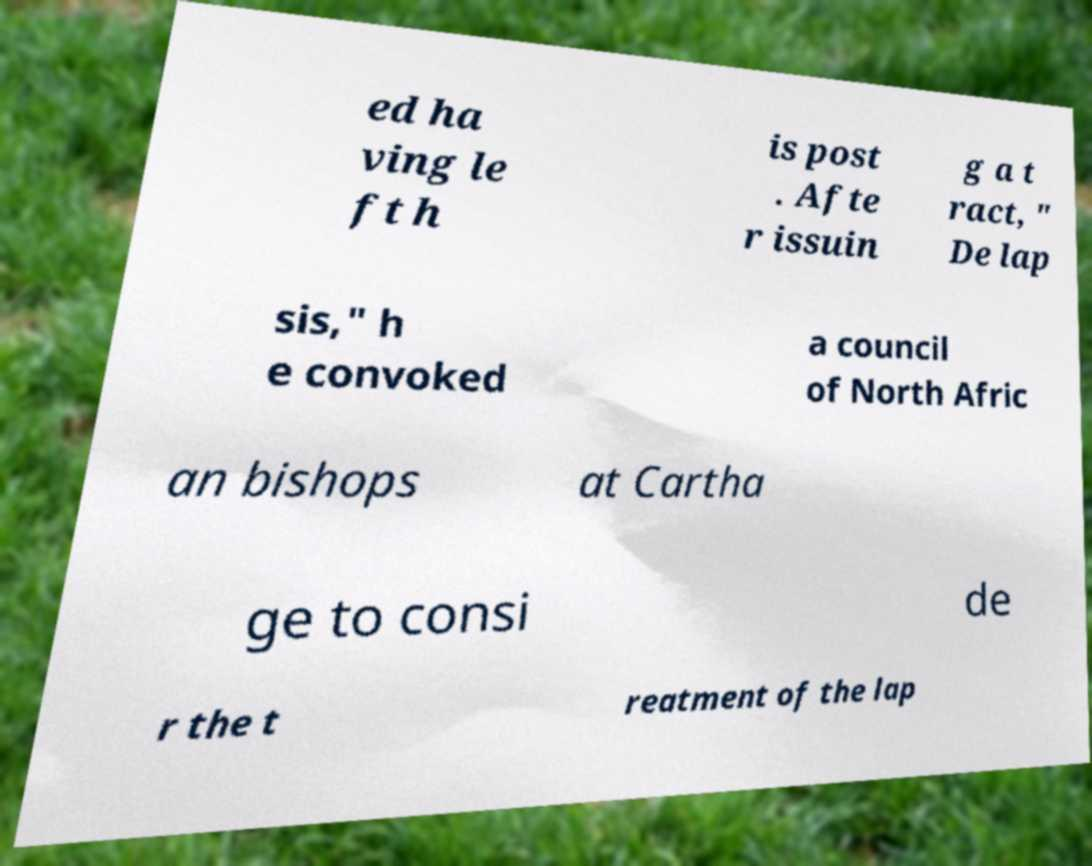Can you read and provide the text displayed in the image?This photo seems to have some interesting text. Can you extract and type it out for me? ed ha ving le ft h is post . Afte r issuin g a t ract, " De lap sis," h e convoked a council of North Afric an bishops at Cartha ge to consi de r the t reatment of the lap 